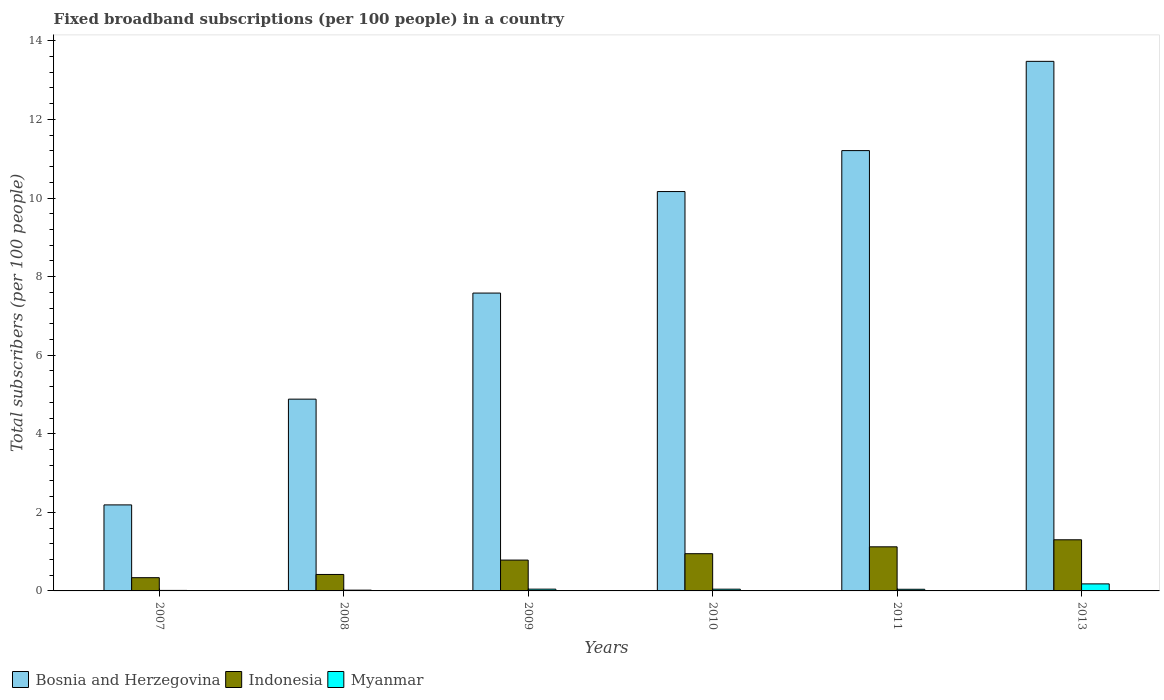Are the number of bars on each tick of the X-axis equal?
Make the answer very short. Yes. In how many cases, is the number of bars for a given year not equal to the number of legend labels?
Your response must be concise. 0. What is the number of broadband subscriptions in Myanmar in 2008?
Make the answer very short. 0.02. Across all years, what is the maximum number of broadband subscriptions in Bosnia and Herzegovina?
Your response must be concise. 13.48. Across all years, what is the minimum number of broadband subscriptions in Bosnia and Herzegovina?
Ensure brevity in your answer.  2.19. What is the total number of broadband subscriptions in Indonesia in the graph?
Your response must be concise. 4.91. What is the difference between the number of broadband subscriptions in Myanmar in 2008 and that in 2009?
Your answer should be very brief. -0.03. What is the difference between the number of broadband subscriptions in Myanmar in 2009 and the number of broadband subscriptions in Bosnia and Herzegovina in 2013?
Your answer should be very brief. -13.43. What is the average number of broadband subscriptions in Bosnia and Herzegovina per year?
Provide a short and direct response. 8.25. In the year 2013, what is the difference between the number of broadband subscriptions in Myanmar and number of broadband subscriptions in Indonesia?
Your response must be concise. -1.12. What is the ratio of the number of broadband subscriptions in Bosnia and Herzegovina in 2007 to that in 2013?
Offer a terse response. 0.16. Is the number of broadband subscriptions in Indonesia in 2007 less than that in 2009?
Your answer should be compact. Yes. Is the difference between the number of broadband subscriptions in Myanmar in 2007 and 2013 greater than the difference between the number of broadband subscriptions in Indonesia in 2007 and 2013?
Your response must be concise. Yes. What is the difference between the highest and the second highest number of broadband subscriptions in Myanmar?
Provide a succinct answer. 0.13. What is the difference between the highest and the lowest number of broadband subscriptions in Indonesia?
Offer a very short reply. 0.96. In how many years, is the number of broadband subscriptions in Bosnia and Herzegovina greater than the average number of broadband subscriptions in Bosnia and Herzegovina taken over all years?
Make the answer very short. 3. Is the sum of the number of broadband subscriptions in Indonesia in 2008 and 2011 greater than the maximum number of broadband subscriptions in Bosnia and Herzegovina across all years?
Provide a short and direct response. No. What does the 1st bar from the left in 2009 represents?
Your answer should be very brief. Bosnia and Herzegovina. What does the 2nd bar from the right in 2011 represents?
Give a very brief answer. Indonesia. How many bars are there?
Provide a succinct answer. 18. How many years are there in the graph?
Make the answer very short. 6. What is the difference between two consecutive major ticks on the Y-axis?
Your response must be concise. 2. Are the values on the major ticks of Y-axis written in scientific E-notation?
Ensure brevity in your answer.  No. Does the graph contain grids?
Provide a succinct answer. No. Where does the legend appear in the graph?
Give a very brief answer. Bottom left. How are the legend labels stacked?
Provide a short and direct response. Horizontal. What is the title of the graph?
Your answer should be compact. Fixed broadband subscriptions (per 100 people) in a country. What is the label or title of the Y-axis?
Your answer should be very brief. Total subscribers (per 100 people). What is the Total subscribers (per 100 people) in Bosnia and Herzegovina in 2007?
Keep it short and to the point. 2.19. What is the Total subscribers (per 100 people) of Indonesia in 2007?
Your answer should be compact. 0.34. What is the Total subscribers (per 100 people) of Myanmar in 2007?
Provide a succinct answer. 0.01. What is the Total subscribers (per 100 people) of Bosnia and Herzegovina in 2008?
Give a very brief answer. 4.88. What is the Total subscribers (per 100 people) of Indonesia in 2008?
Your answer should be very brief. 0.42. What is the Total subscribers (per 100 people) of Myanmar in 2008?
Ensure brevity in your answer.  0.02. What is the Total subscribers (per 100 people) in Bosnia and Herzegovina in 2009?
Make the answer very short. 7.58. What is the Total subscribers (per 100 people) in Indonesia in 2009?
Provide a succinct answer. 0.78. What is the Total subscribers (per 100 people) in Myanmar in 2009?
Ensure brevity in your answer.  0.05. What is the Total subscribers (per 100 people) of Bosnia and Herzegovina in 2010?
Offer a terse response. 10.16. What is the Total subscribers (per 100 people) of Indonesia in 2010?
Offer a terse response. 0.95. What is the Total subscribers (per 100 people) in Myanmar in 2010?
Provide a succinct answer. 0.04. What is the Total subscribers (per 100 people) in Bosnia and Herzegovina in 2011?
Make the answer very short. 11.21. What is the Total subscribers (per 100 people) of Indonesia in 2011?
Provide a succinct answer. 1.12. What is the Total subscribers (per 100 people) in Myanmar in 2011?
Offer a terse response. 0.04. What is the Total subscribers (per 100 people) of Bosnia and Herzegovina in 2013?
Keep it short and to the point. 13.48. What is the Total subscribers (per 100 people) in Indonesia in 2013?
Offer a terse response. 1.3. What is the Total subscribers (per 100 people) in Myanmar in 2013?
Your answer should be very brief. 0.18. Across all years, what is the maximum Total subscribers (per 100 people) of Bosnia and Herzegovina?
Your response must be concise. 13.48. Across all years, what is the maximum Total subscribers (per 100 people) of Indonesia?
Provide a short and direct response. 1.3. Across all years, what is the maximum Total subscribers (per 100 people) of Myanmar?
Make the answer very short. 0.18. Across all years, what is the minimum Total subscribers (per 100 people) of Bosnia and Herzegovina?
Offer a terse response. 2.19. Across all years, what is the minimum Total subscribers (per 100 people) in Indonesia?
Your answer should be compact. 0.34. Across all years, what is the minimum Total subscribers (per 100 people) of Myanmar?
Your response must be concise. 0.01. What is the total Total subscribers (per 100 people) in Bosnia and Herzegovina in the graph?
Keep it short and to the point. 49.5. What is the total Total subscribers (per 100 people) of Indonesia in the graph?
Offer a very short reply. 4.91. What is the total Total subscribers (per 100 people) of Myanmar in the graph?
Offer a terse response. 0.34. What is the difference between the Total subscribers (per 100 people) of Bosnia and Herzegovina in 2007 and that in 2008?
Provide a short and direct response. -2.69. What is the difference between the Total subscribers (per 100 people) in Indonesia in 2007 and that in 2008?
Make the answer very short. -0.08. What is the difference between the Total subscribers (per 100 people) in Myanmar in 2007 and that in 2008?
Provide a short and direct response. -0.01. What is the difference between the Total subscribers (per 100 people) in Bosnia and Herzegovina in 2007 and that in 2009?
Provide a short and direct response. -5.39. What is the difference between the Total subscribers (per 100 people) in Indonesia in 2007 and that in 2009?
Give a very brief answer. -0.45. What is the difference between the Total subscribers (per 100 people) in Myanmar in 2007 and that in 2009?
Make the answer very short. -0.03. What is the difference between the Total subscribers (per 100 people) in Bosnia and Herzegovina in 2007 and that in 2010?
Offer a terse response. -7.97. What is the difference between the Total subscribers (per 100 people) in Indonesia in 2007 and that in 2010?
Your answer should be compact. -0.61. What is the difference between the Total subscribers (per 100 people) of Myanmar in 2007 and that in 2010?
Provide a short and direct response. -0.03. What is the difference between the Total subscribers (per 100 people) in Bosnia and Herzegovina in 2007 and that in 2011?
Your answer should be very brief. -9.02. What is the difference between the Total subscribers (per 100 people) in Indonesia in 2007 and that in 2011?
Your response must be concise. -0.79. What is the difference between the Total subscribers (per 100 people) in Myanmar in 2007 and that in 2011?
Make the answer very short. -0.03. What is the difference between the Total subscribers (per 100 people) in Bosnia and Herzegovina in 2007 and that in 2013?
Provide a short and direct response. -11.29. What is the difference between the Total subscribers (per 100 people) in Indonesia in 2007 and that in 2013?
Ensure brevity in your answer.  -0.96. What is the difference between the Total subscribers (per 100 people) in Myanmar in 2007 and that in 2013?
Make the answer very short. -0.17. What is the difference between the Total subscribers (per 100 people) in Bosnia and Herzegovina in 2008 and that in 2009?
Offer a terse response. -2.7. What is the difference between the Total subscribers (per 100 people) in Indonesia in 2008 and that in 2009?
Your answer should be compact. -0.37. What is the difference between the Total subscribers (per 100 people) of Myanmar in 2008 and that in 2009?
Provide a succinct answer. -0.03. What is the difference between the Total subscribers (per 100 people) in Bosnia and Herzegovina in 2008 and that in 2010?
Your response must be concise. -5.28. What is the difference between the Total subscribers (per 100 people) of Indonesia in 2008 and that in 2010?
Make the answer very short. -0.53. What is the difference between the Total subscribers (per 100 people) of Myanmar in 2008 and that in 2010?
Offer a very short reply. -0.02. What is the difference between the Total subscribers (per 100 people) of Bosnia and Herzegovina in 2008 and that in 2011?
Give a very brief answer. -6.33. What is the difference between the Total subscribers (per 100 people) in Indonesia in 2008 and that in 2011?
Offer a very short reply. -0.7. What is the difference between the Total subscribers (per 100 people) in Myanmar in 2008 and that in 2011?
Your answer should be very brief. -0.02. What is the difference between the Total subscribers (per 100 people) of Bosnia and Herzegovina in 2008 and that in 2013?
Keep it short and to the point. -8.6. What is the difference between the Total subscribers (per 100 people) in Indonesia in 2008 and that in 2013?
Your answer should be very brief. -0.88. What is the difference between the Total subscribers (per 100 people) of Myanmar in 2008 and that in 2013?
Offer a very short reply. -0.16. What is the difference between the Total subscribers (per 100 people) of Bosnia and Herzegovina in 2009 and that in 2010?
Keep it short and to the point. -2.58. What is the difference between the Total subscribers (per 100 people) of Indonesia in 2009 and that in 2010?
Keep it short and to the point. -0.16. What is the difference between the Total subscribers (per 100 people) of Myanmar in 2009 and that in 2010?
Your response must be concise. 0. What is the difference between the Total subscribers (per 100 people) in Bosnia and Herzegovina in 2009 and that in 2011?
Offer a very short reply. -3.63. What is the difference between the Total subscribers (per 100 people) of Indonesia in 2009 and that in 2011?
Keep it short and to the point. -0.34. What is the difference between the Total subscribers (per 100 people) in Myanmar in 2009 and that in 2011?
Provide a succinct answer. 0. What is the difference between the Total subscribers (per 100 people) of Bosnia and Herzegovina in 2009 and that in 2013?
Keep it short and to the point. -5.9. What is the difference between the Total subscribers (per 100 people) in Indonesia in 2009 and that in 2013?
Keep it short and to the point. -0.52. What is the difference between the Total subscribers (per 100 people) of Myanmar in 2009 and that in 2013?
Offer a very short reply. -0.13. What is the difference between the Total subscribers (per 100 people) of Bosnia and Herzegovina in 2010 and that in 2011?
Offer a very short reply. -1.04. What is the difference between the Total subscribers (per 100 people) of Indonesia in 2010 and that in 2011?
Offer a very short reply. -0.17. What is the difference between the Total subscribers (per 100 people) in Myanmar in 2010 and that in 2011?
Your response must be concise. 0. What is the difference between the Total subscribers (per 100 people) in Bosnia and Herzegovina in 2010 and that in 2013?
Give a very brief answer. -3.31. What is the difference between the Total subscribers (per 100 people) of Indonesia in 2010 and that in 2013?
Provide a short and direct response. -0.35. What is the difference between the Total subscribers (per 100 people) of Myanmar in 2010 and that in 2013?
Offer a very short reply. -0.13. What is the difference between the Total subscribers (per 100 people) in Bosnia and Herzegovina in 2011 and that in 2013?
Your answer should be compact. -2.27. What is the difference between the Total subscribers (per 100 people) of Indonesia in 2011 and that in 2013?
Ensure brevity in your answer.  -0.18. What is the difference between the Total subscribers (per 100 people) in Myanmar in 2011 and that in 2013?
Ensure brevity in your answer.  -0.14. What is the difference between the Total subscribers (per 100 people) in Bosnia and Herzegovina in 2007 and the Total subscribers (per 100 people) in Indonesia in 2008?
Ensure brevity in your answer.  1.77. What is the difference between the Total subscribers (per 100 people) of Bosnia and Herzegovina in 2007 and the Total subscribers (per 100 people) of Myanmar in 2008?
Provide a short and direct response. 2.17. What is the difference between the Total subscribers (per 100 people) in Indonesia in 2007 and the Total subscribers (per 100 people) in Myanmar in 2008?
Offer a very short reply. 0.32. What is the difference between the Total subscribers (per 100 people) in Bosnia and Herzegovina in 2007 and the Total subscribers (per 100 people) in Indonesia in 2009?
Your answer should be very brief. 1.4. What is the difference between the Total subscribers (per 100 people) in Bosnia and Herzegovina in 2007 and the Total subscribers (per 100 people) in Myanmar in 2009?
Offer a terse response. 2.14. What is the difference between the Total subscribers (per 100 people) in Indonesia in 2007 and the Total subscribers (per 100 people) in Myanmar in 2009?
Your response must be concise. 0.29. What is the difference between the Total subscribers (per 100 people) of Bosnia and Herzegovina in 2007 and the Total subscribers (per 100 people) of Indonesia in 2010?
Provide a succinct answer. 1.24. What is the difference between the Total subscribers (per 100 people) in Bosnia and Herzegovina in 2007 and the Total subscribers (per 100 people) in Myanmar in 2010?
Your answer should be compact. 2.15. What is the difference between the Total subscribers (per 100 people) of Indonesia in 2007 and the Total subscribers (per 100 people) of Myanmar in 2010?
Your response must be concise. 0.29. What is the difference between the Total subscribers (per 100 people) in Bosnia and Herzegovina in 2007 and the Total subscribers (per 100 people) in Indonesia in 2011?
Give a very brief answer. 1.07. What is the difference between the Total subscribers (per 100 people) in Bosnia and Herzegovina in 2007 and the Total subscribers (per 100 people) in Myanmar in 2011?
Your answer should be compact. 2.15. What is the difference between the Total subscribers (per 100 people) of Indonesia in 2007 and the Total subscribers (per 100 people) of Myanmar in 2011?
Give a very brief answer. 0.3. What is the difference between the Total subscribers (per 100 people) of Bosnia and Herzegovina in 2007 and the Total subscribers (per 100 people) of Indonesia in 2013?
Provide a short and direct response. 0.89. What is the difference between the Total subscribers (per 100 people) in Bosnia and Herzegovina in 2007 and the Total subscribers (per 100 people) in Myanmar in 2013?
Keep it short and to the point. 2.01. What is the difference between the Total subscribers (per 100 people) of Indonesia in 2007 and the Total subscribers (per 100 people) of Myanmar in 2013?
Provide a succinct answer. 0.16. What is the difference between the Total subscribers (per 100 people) of Bosnia and Herzegovina in 2008 and the Total subscribers (per 100 people) of Indonesia in 2009?
Keep it short and to the point. 4.1. What is the difference between the Total subscribers (per 100 people) in Bosnia and Herzegovina in 2008 and the Total subscribers (per 100 people) in Myanmar in 2009?
Provide a succinct answer. 4.84. What is the difference between the Total subscribers (per 100 people) of Indonesia in 2008 and the Total subscribers (per 100 people) of Myanmar in 2009?
Your answer should be compact. 0.37. What is the difference between the Total subscribers (per 100 people) of Bosnia and Herzegovina in 2008 and the Total subscribers (per 100 people) of Indonesia in 2010?
Provide a succinct answer. 3.93. What is the difference between the Total subscribers (per 100 people) of Bosnia and Herzegovina in 2008 and the Total subscribers (per 100 people) of Myanmar in 2010?
Offer a terse response. 4.84. What is the difference between the Total subscribers (per 100 people) of Indonesia in 2008 and the Total subscribers (per 100 people) of Myanmar in 2010?
Provide a succinct answer. 0.37. What is the difference between the Total subscribers (per 100 people) in Bosnia and Herzegovina in 2008 and the Total subscribers (per 100 people) in Indonesia in 2011?
Your answer should be very brief. 3.76. What is the difference between the Total subscribers (per 100 people) in Bosnia and Herzegovina in 2008 and the Total subscribers (per 100 people) in Myanmar in 2011?
Keep it short and to the point. 4.84. What is the difference between the Total subscribers (per 100 people) in Indonesia in 2008 and the Total subscribers (per 100 people) in Myanmar in 2011?
Offer a very short reply. 0.38. What is the difference between the Total subscribers (per 100 people) in Bosnia and Herzegovina in 2008 and the Total subscribers (per 100 people) in Indonesia in 2013?
Your response must be concise. 3.58. What is the difference between the Total subscribers (per 100 people) of Bosnia and Herzegovina in 2008 and the Total subscribers (per 100 people) of Myanmar in 2013?
Provide a succinct answer. 4.7. What is the difference between the Total subscribers (per 100 people) in Indonesia in 2008 and the Total subscribers (per 100 people) in Myanmar in 2013?
Provide a short and direct response. 0.24. What is the difference between the Total subscribers (per 100 people) of Bosnia and Herzegovina in 2009 and the Total subscribers (per 100 people) of Indonesia in 2010?
Your response must be concise. 6.63. What is the difference between the Total subscribers (per 100 people) in Bosnia and Herzegovina in 2009 and the Total subscribers (per 100 people) in Myanmar in 2010?
Your answer should be very brief. 7.54. What is the difference between the Total subscribers (per 100 people) in Indonesia in 2009 and the Total subscribers (per 100 people) in Myanmar in 2010?
Your response must be concise. 0.74. What is the difference between the Total subscribers (per 100 people) of Bosnia and Herzegovina in 2009 and the Total subscribers (per 100 people) of Indonesia in 2011?
Your answer should be compact. 6.46. What is the difference between the Total subscribers (per 100 people) of Bosnia and Herzegovina in 2009 and the Total subscribers (per 100 people) of Myanmar in 2011?
Offer a very short reply. 7.54. What is the difference between the Total subscribers (per 100 people) of Indonesia in 2009 and the Total subscribers (per 100 people) of Myanmar in 2011?
Provide a succinct answer. 0.74. What is the difference between the Total subscribers (per 100 people) of Bosnia and Herzegovina in 2009 and the Total subscribers (per 100 people) of Indonesia in 2013?
Give a very brief answer. 6.28. What is the difference between the Total subscribers (per 100 people) of Bosnia and Herzegovina in 2009 and the Total subscribers (per 100 people) of Myanmar in 2013?
Provide a succinct answer. 7.4. What is the difference between the Total subscribers (per 100 people) of Indonesia in 2009 and the Total subscribers (per 100 people) of Myanmar in 2013?
Make the answer very short. 0.61. What is the difference between the Total subscribers (per 100 people) in Bosnia and Herzegovina in 2010 and the Total subscribers (per 100 people) in Indonesia in 2011?
Offer a terse response. 9.04. What is the difference between the Total subscribers (per 100 people) of Bosnia and Herzegovina in 2010 and the Total subscribers (per 100 people) of Myanmar in 2011?
Offer a terse response. 10.12. What is the difference between the Total subscribers (per 100 people) of Indonesia in 2010 and the Total subscribers (per 100 people) of Myanmar in 2011?
Your answer should be compact. 0.91. What is the difference between the Total subscribers (per 100 people) in Bosnia and Herzegovina in 2010 and the Total subscribers (per 100 people) in Indonesia in 2013?
Provide a short and direct response. 8.86. What is the difference between the Total subscribers (per 100 people) in Bosnia and Herzegovina in 2010 and the Total subscribers (per 100 people) in Myanmar in 2013?
Your answer should be very brief. 9.99. What is the difference between the Total subscribers (per 100 people) in Indonesia in 2010 and the Total subscribers (per 100 people) in Myanmar in 2013?
Your answer should be very brief. 0.77. What is the difference between the Total subscribers (per 100 people) in Bosnia and Herzegovina in 2011 and the Total subscribers (per 100 people) in Indonesia in 2013?
Your answer should be very brief. 9.9. What is the difference between the Total subscribers (per 100 people) of Bosnia and Herzegovina in 2011 and the Total subscribers (per 100 people) of Myanmar in 2013?
Offer a terse response. 11.03. What is the difference between the Total subscribers (per 100 people) of Indonesia in 2011 and the Total subscribers (per 100 people) of Myanmar in 2013?
Your response must be concise. 0.94. What is the average Total subscribers (per 100 people) of Bosnia and Herzegovina per year?
Provide a short and direct response. 8.25. What is the average Total subscribers (per 100 people) of Indonesia per year?
Your answer should be very brief. 0.82. What is the average Total subscribers (per 100 people) of Myanmar per year?
Keep it short and to the point. 0.06. In the year 2007, what is the difference between the Total subscribers (per 100 people) in Bosnia and Herzegovina and Total subscribers (per 100 people) in Indonesia?
Your answer should be compact. 1.85. In the year 2007, what is the difference between the Total subscribers (per 100 people) in Bosnia and Herzegovina and Total subscribers (per 100 people) in Myanmar?
Make the answer very short. 2.18. In the year 2007, what is the difference between the Total subscribers (per 100 people) of Indonesia and Total subscribers (per 100 people) of Myanmar?
Give a very brief answer. 0.32. In the year 2008, what is the difference between the Total subscribers (per 100 people) of Bosnia and Herzegovina and Total subscribers (per 100 people) of Indonesia?
Give a very brief answer. 4.46. In the year 2008, what is the difference between the Total subscribers (per 100 people) in Bosnia and Herzegovina and Total subscribers (per 100 people) in Myanmar?
Your answer should be very brief. 4.86. In the year 2008, what is the difference between the Total subscribers (per 100 people) in Indonesia and Total subscribers (per 100 people) in Myanmar?
Offer a very short reply. 0.4. In the year 2009, what is the difference between the Total subscribers (per 100 people) of Bosnia and Herzegovina and Total subscribers (per 100 people) of Indonesia?
Your answer should be compact. 6.8. In the year 2009, what is the difference between the Total subscribers (per 100 people) in Bosnia and Herzegovina and Total subscribers (per 100 people) in Myanmar?
Provide a succinct answer. 7.54. In the year 2009, what is the difference between the Total subscribers (per 100 people) of Indonesia and Total subscribers (per 100 people) of Myanmar?
Your answer should be compact. 0.74. In the year 2010, what is the difference between the Total subscribers (per 100 people) in Bosnia and Herzegovina and Total subscribers (per 100 people) in Indonesia?
Provide a short and direct response. 9.22. In the year 2010, what is the difference between the Total subscribers (per 100 people) of Bosnia and Herzegovina and Total subscribers (per 100 people) of Myanmar?
Provide a succinct answer. 10.12. In the year 2010, what is the difference between the Total subscribers (per 100 people) of Indonesia and Total subscribers (per 100 people) of Myanmar?
Keep it short and to the point. 0.9. In the year 2011, what is the difference between the Total subscribers (per 100 people) of Bosnia and Herzegovina and Total subscribers (per 100 people) of Indonesia?
Provide a succinct answer. 10.08. In the year 2011, what is the difference between the Total subscribers (per 100 people) of Bosnia and Herzegovina and Total subscribers (per 100 people) of Myanmar?
Your answer should be compact. 11.16. In the year 2011, what is the difference between the Total subscribers (per 100 people) of Indonesia and Total subscribers (per 100 people) of Myanmar?
Ensure brevity in your answer.  1.08. In the year 2013, what is the difference between the Total subscribers (per 100 people) of Bosnia and Herzegovina and Total subscribers (per 100 people) of Indonesia?
Keep it short and to the point. 12.18. In the year 2013, what is the difference between the Total subscribers (per 100 people) of Bosnia and Herzegovina and Total subscribers (per 100 people) of Myanmar?
Ensure brevity in your answer.  13.3. In the year 2013, what is the difference between the Total subscribers (per 100 people) of Indonesia and Total subscribers (per 100 people) of Myanmar?
Provide a short and direct response. 1.12. What is the ratio of the Total subscribers (per 100 people) in Bosnia and Herzegovina in 2007 to that in 2008?
Give a very brief answer. 0.45. What is the ratio of the Total subscribers (per 100 people) in Indonesia in 2007 to that in 2008?
Ensure brevity in your answer.  0.8. What is the ratio of the Total subscribers (per 100 people) of Myanmar in 2007 to that in 2008?
Ensure brevity in your answer.  0.65. What is the ratio of the Total subscribers (per 100 people) of Bosnia and Herzegovina in 2007 to that in 2009?
Provide a succinct answer. 0.29. What is the ratio of the Total subscribers (per 100 people) in Indonesia in 2007 to that in 2009?
Keep it short and to the point. 0.43. What is the ratio of the Total subscribers (per 100 people) of Myanmar in 2007 to that in 2009?
Provide a succinct answer. 0.28. What is the ratio of the Total subscribers (per 100 people) of Bosnia and Herzegovina in 2007 to that in 2010?
Your answer should be very brief. 0.22. What is the ratio of the Total subscribers (per 100 people) in Indonesia in 2007 to that in 2010?
Your answer should be compact. 0.36. What is the ratio of the Total subscribers (per 100 people) of Myanmar in 2007 to that in 2010?
Provide a short and direct response. 0.29. What is the ratio of the Total subscribers (per 100 people) of Bosnia and Herzegovina in 2007 to that in 2011?
Keep it short and to the point. 0.2. What is the ratio of the Total subscribers (per 100 people) of Indonesia in 2007 to that in 2011?
Ensure brevity in your answer.  0.3. What is the ratio of the Total subscribers (per 100 people) of Myanmar in 2007 to that in 2011?
Your answer should be compact. 0.3. What is the ratio of the Total subscribers (per 100 people) of Bosnia and Herzegovina in 2007 to that in 2013?
Your answer should be compact. 0.16. What is the ratio of the Total subscribers (per 100 people) in Indonesia in 2007 to that in 2013?
Ensure brevity in your answer.  0.26. What is the ratio of the Total subscribers (per 100 people) of Myanmar in 2007 to that in 2013?
Your answer should be compact. 0.07. What is the ratio of the Total subscribers (per 100 people) in Bosnia and Herzegovina in 2008 to that in 2009?
Ensure brevity in your answer.  0.64. What is the ratio of the Total subscribers (per 100 people) of Indonesia in 2008 to that in 2009?
Keep it short and to the point. 0.53. What is the ratio of the Total subscribers (per 100 people) of Myanmar in 2008 to that in 2009?
Offer a very short reply. 0.43. What is the ratio of the Total subscribers (per 100 people) of Bosnia and Herzegovina in 2008 to that in 2010?
Offer a very short reply. 0.48. What is the ratio of the Total subscribers (per 100 people) in Indonesia in 2008 to that in 2010?
Your answer should be compact. 0.44. What is the ratio of the Total subscribers (per 100 people) of Myanmar in 2008 to that in 2010?
Give a very brief answer. 0.44. What is the ratio of the Total subscribers (per 100 people) of Bosnia and Herzegovina in 2008 to that in 2011?
Keep it short and to the point. 0.44. What is the ratio of the Total subscribers (per 100 people) in Indonesia in 2008 to that in 2011?
Your response must be concise. 0.37. What is the ratio of the Total subscribers (per 100 people) of Myanmar in 2008 to that in 2011?
Your response must be concise. 0.47. What is the ratio of the Total subscribers (per 100 people) in Bosnia and Herzegovina in 2008 to that in 2013?
Your response must be concise. 0.36. What is the ratio of the Total subscribers (per 100 people) of Indonesia in 2008 to that in 2013?
Provide a succinct answer. 0.32. What is the ratio of the Total subscribers (per 100 people) in Myanmar in 2008 to that in 2013?
Provide a short and direct response. 0.11. What is the ratio of the Total subscribers (per 100 people) in Bosnia and Herzegovina in 2009 to that in 2010?
Give a very brief answer. 0.75. What is the ratio of the Total subscribers (per 100 people) of Indonesia in 2009 to that in 2010?
Provide a short and direct response. 0.83. What is the ratio of the Total subscribers (per 100 people) of Myanmar in 2009 to that in 2010?
Offer a terse response. 1.02. What is the ratio of the Total subscribers (per 100 people) of Bosnia and Herzegovina in 2009 to that in 2011?
Your answer should be compact. 0.68. What is the ratio of the Total subscribers (per 100 people) of Indonesia in 2009 to that in 2011?
Your answer should be very brief. 0.7. What is the ratio of the Total subscribers (per 100 people) of Myanmar in 2009 to that in 2011?
Offer a very short reply. 1.08. What is the ratio of the Total subscribers (per 100 people) in Bosnia and Herzegovina in 2009 to that in 2013?
Your answer should be very brief. 0.56. What is the ratio of the Total subscribers (per 100 people) in Indonesia in 2009 to that in 2013?
Keep it short and to the point. 0.6. What is the ratio of the Total subscribers (per 100 people) of Myanmar in 2009 to that in 2013?
Your answer should be very brief. 0.25. What is the ratio of the Total subscribers (per 100 people) of Bosnia and Herzegovina in 2010 to that in 2011?
Offer a terse response. 0.91. What is the ratio of the Total subscribers (per 100 people) of Indonesia in 2010 to that in 2011?
Your answer should be compact. 0.84. What is the ratio of the Total subscribers (per 100 people) in Myanmar in 2010 to that in 2011?
Your response must be concise. 1.06. What is the ratio of the Total subscribers (per 100 people) of Bosnia and Herzegovina in 2010 to that in 2013?
Provide a short and direct response. 0.75. What is the ratio of the Total subscribers (per 100 people) of Indonesia in 2010 to that in 2013?
Your answer should be very brief. 0.73. What is the ratio of the Total subscribers (per 100 people) of Myanmar in 2010 to that in 2013?
Ensure brevity in your answer.  0.25. What is the ratio of the Total subscribers (per 100 people) in Bosnia and Herzegovina in 2011 to that in 2013?
Offer a terse response. 0.83. What is the ratio of the Total subscribers (per 100 people) in Indonesia in 2011 to that in 2013?
Your answer should be compact. 0.86. What is the ratio of the Total subscribers (per 100 people) of Myanmar in 2011 to that in 2013?
Offer a very short reply. 0.23. What is the difference between the highest and the second highest Total subscribers (per 100 people) in Bosnia and Herzegovina?
Make the answer very short. 2.27. What is the difference between the highest and the second highest Total subscribers (per 100 people) in Indonesia?
Provide a short and direct response. 0.18. What is the difference between the highest and the second highest Total subscribers (per 100 people) in Myanmar?
Your response must be concise. 0.13. What is the difference between the highest and the lowest Total subscribers (per 100 people) of Bosnia and Herzegovina?
Offer a terse response. 11.29. What is the difference between the highest and the lowest Total subscribers (per 100 people) of Indonesia?
Your answer should be compact. 0.96. What is the difference between the highest and the lowest Total subscribers (per 100 people) in Myanmar?
Give a very brief answer. 0.17. 